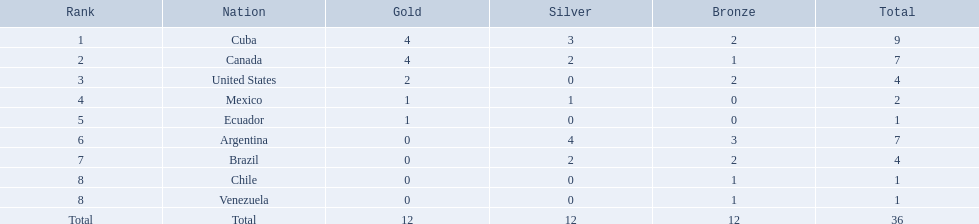What countries achieved medals at the 2011 pan american games in the canoeing discipline? Cuba, Canada, United States, Mexico, Ecuador, Argentina, Brazil, Chile, Venezuela. Which of these countries earned bronze medals? Cuba, Canada, United States, Argentina, Brazil, Chile, Venezuela. Of these countries, which one garnered the most bronze medals? Argentina. Which countries secured medals in the canoeing event during the 2011 pan american games? Cuba, Canada, United States, Mexico, Ecuador, Argentina, Brazil, Chile, Venezuela. Which ones received bronze medals? Cuba, Canada, United States, Argentina, Brazil, Chile, Venezuela. Out of these, who had the most bronze medal wins? Argentina. 